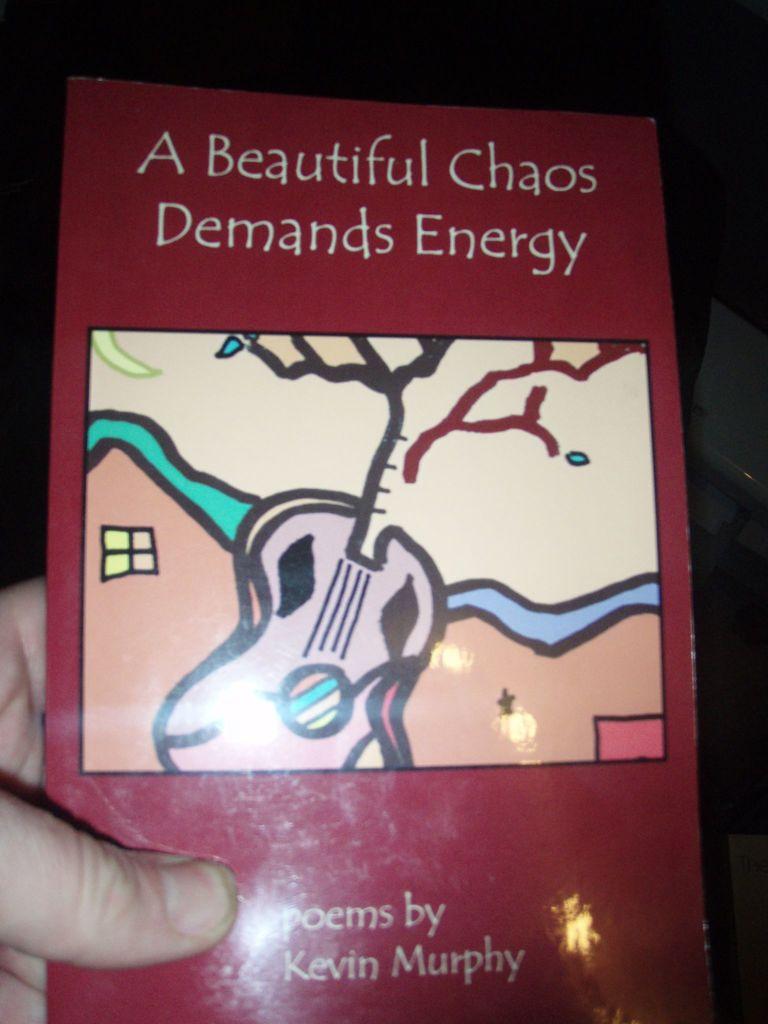Who wrote these poems?
Provide a short and direct response. Kevin murphy. 